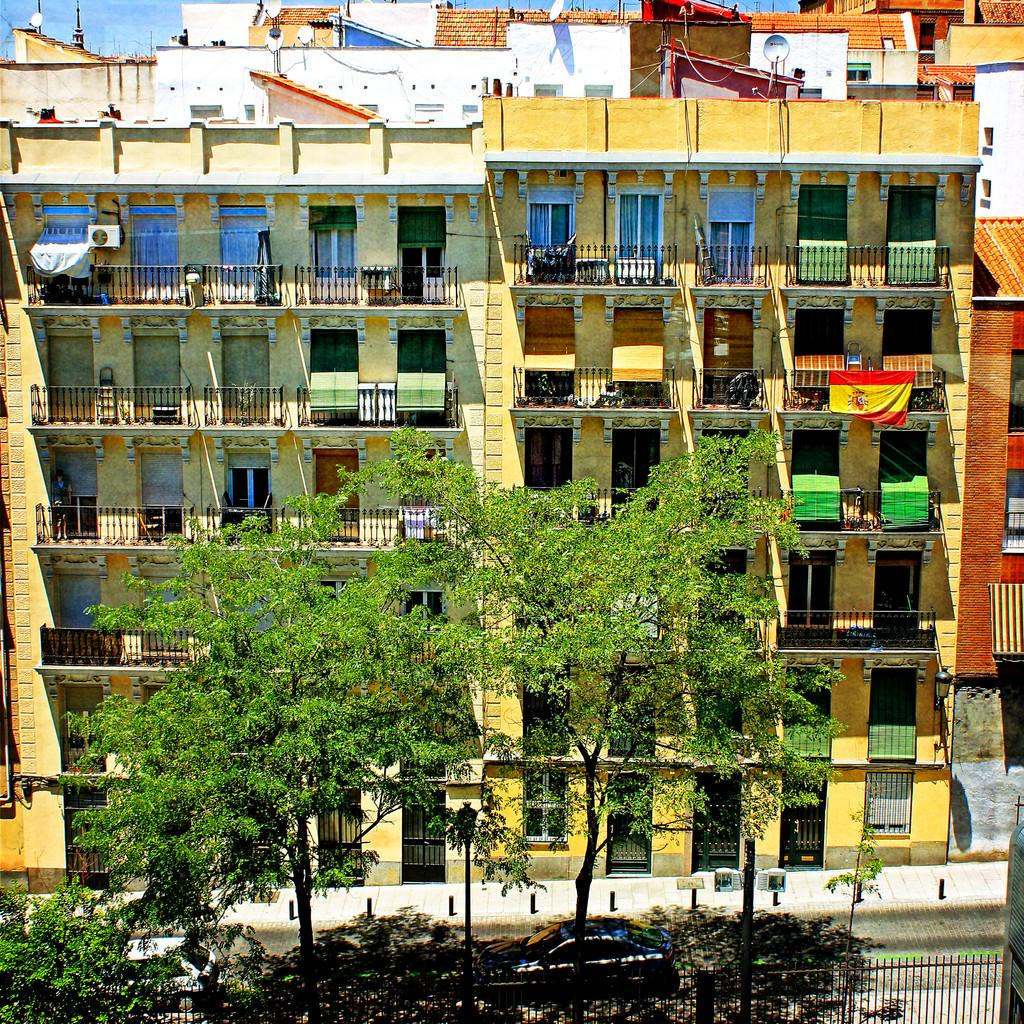What type of structures can be seen in the image? There are buildings in the image. What other natural elements are present in the image? There are trees in the image. What separates the foreground from the background in the image? There is a fence at the bottom of the image. What mode of transportation can be seen in the image? Cars are visible on the road. What part of the natural environment is visible in the background of the image? There is sky visible in the background of the image. What type of tent can be seen in the image? There is no tent present in the image. What is your opinion on the stitching of the buildings in the image? The provided facts do not mention any stitching or opinions, as the conversation is focused on describing the image accurately. 